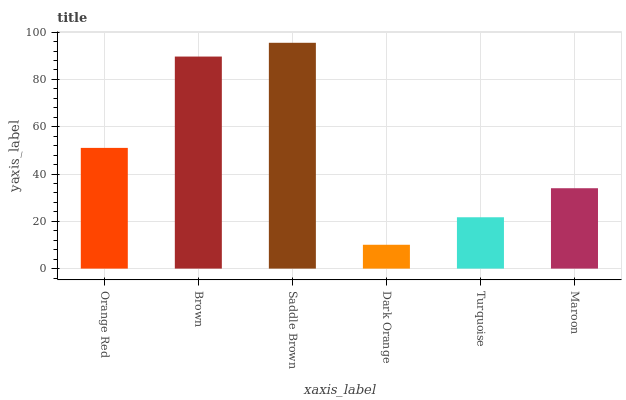Is Brown the minimum?
Answer yes or no. No. Is Brown the maximum?
Answer yes or no. No. Is Brown greater than Orange Red?
Answer yes or no. Yes. Is Orange Red less than Brown?
Answer yes or no. Yes. Is Orange Red greater than Brown?
Answer yes or no. No. Is Brown less than Orange Red?
Answer yes or no. No. Is Orange Red the high median?
Answer yes or no. Yes. Is Maroon the low median?
Answer yes or no. Yes. Is Saddle Brown the high median?
Answer yes or no. No. Is Brown the low median?
Answer yes or no. No. 